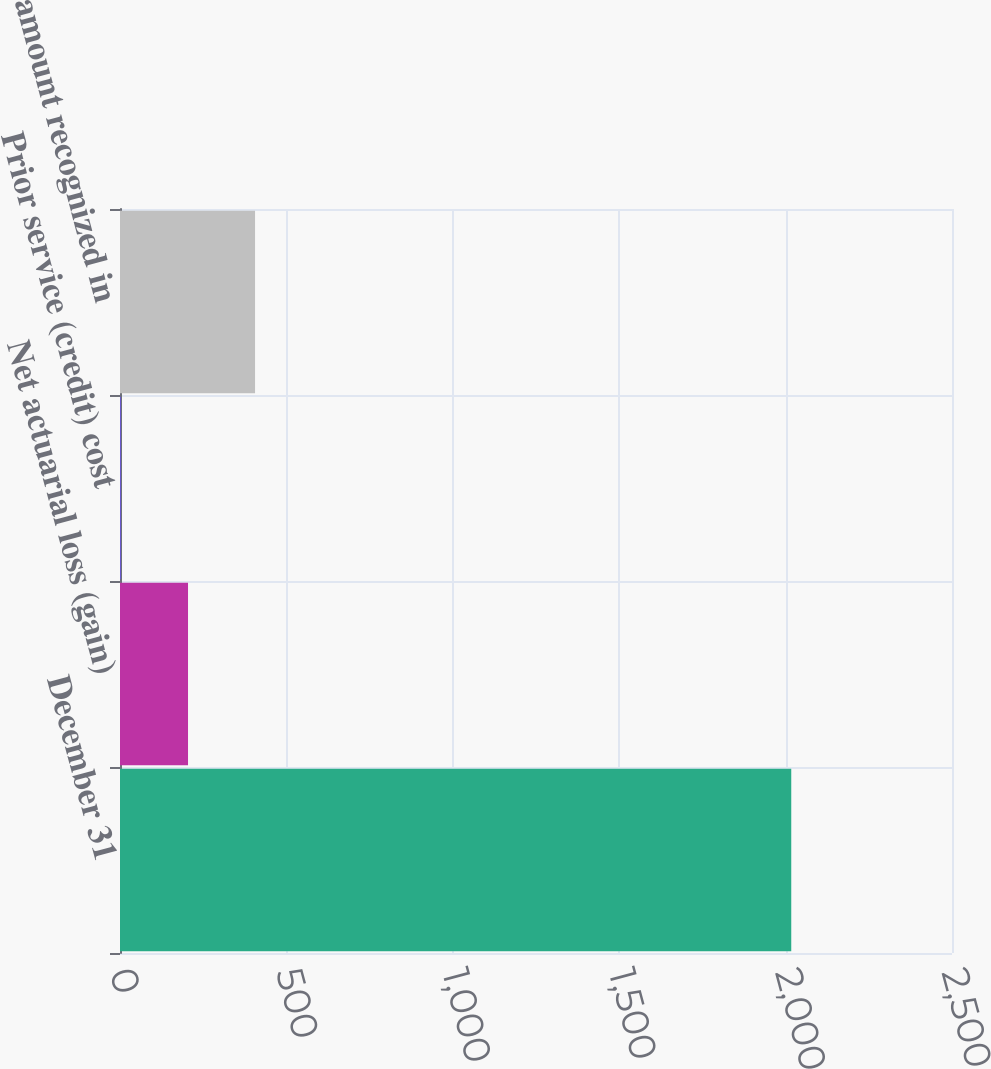<chart> <loc_0><loc_0><loc_500><loc_500><bar_chart><fcel>December 31<fcel>Net actuarial loss (gain)<fcel>Prior service (credit) cost<fcel>Total amount recognized in<nl><fcel>2017<fcel>204.4<fcel>3<fcel>405.8<nl></chart> 